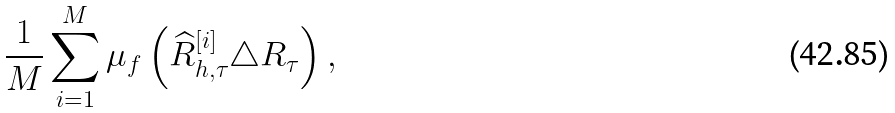Convert formula to latex. <formula><loc_0><loc_0><loc_500><loc_500>\frac { 1 } { M } \sum _ { i = 1 } ^ { M } \mu _ { f } \left ( \widehat { R } _ { h , \tau } ^ { [ i ] } \triangle R _ { \tau } \right ) ,</formula> 